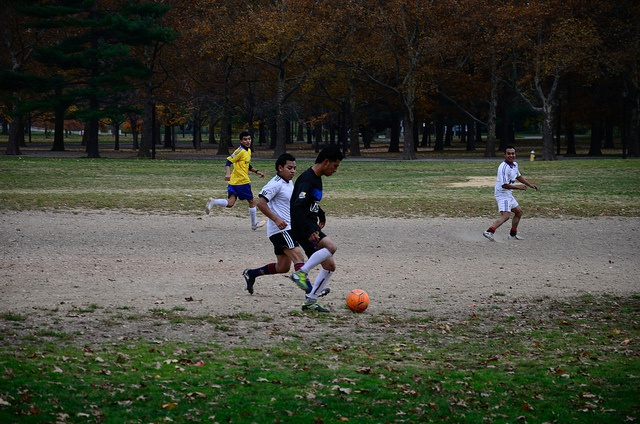Describe the objects in this image and their specific colors. I can see people in black, gray, darkgray, and maroon tones, people in black, darkgray, maroon, and gray tones, people in black, gray, olive, and navy tones, people in black, gray, and darkgray tones, and sports ball in black, maroon, salmon, and red tones in this image. 